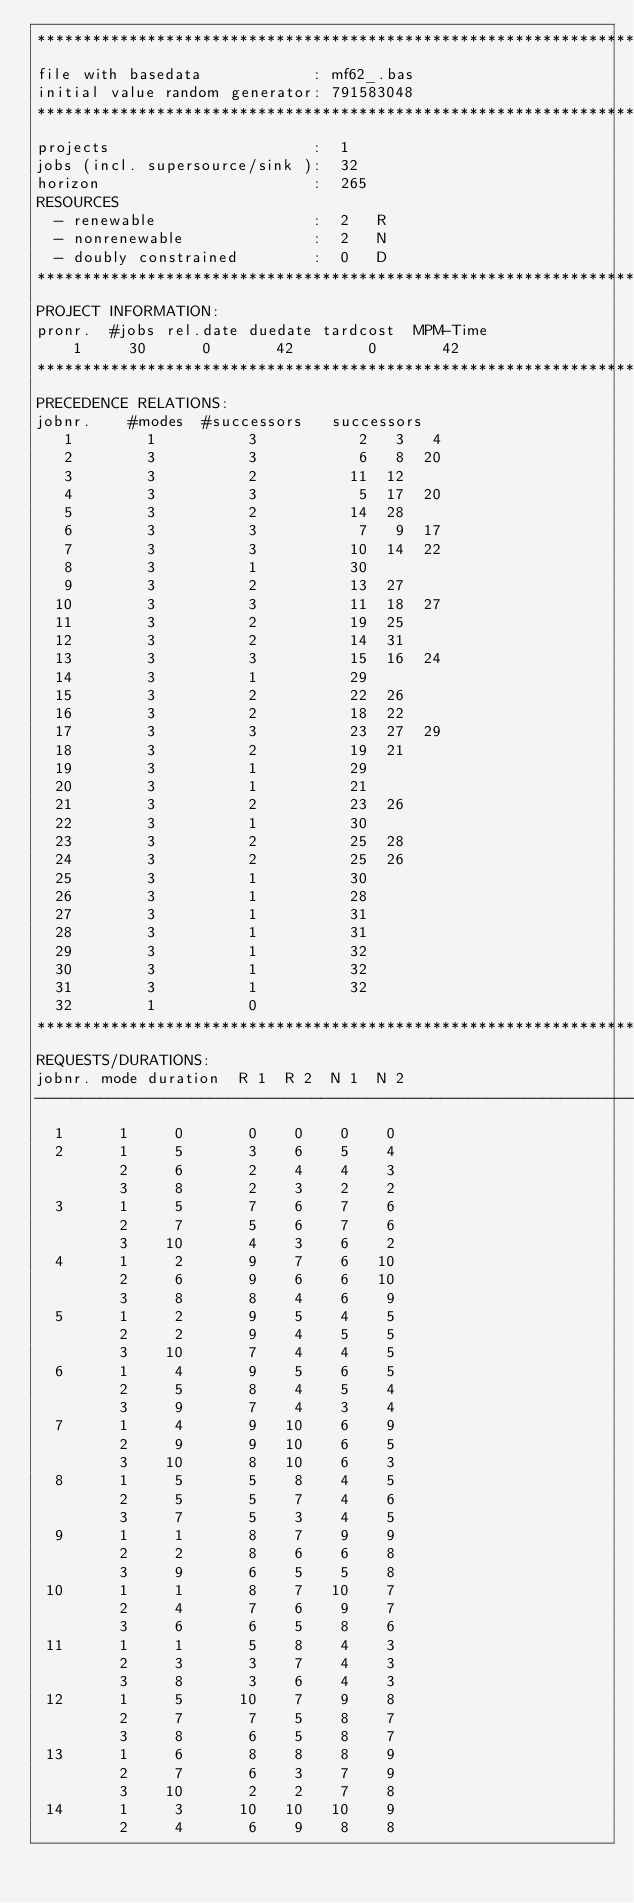<code> <loc_0><loc_0><loc_500><loc_500><_ObjectiveC_>************************************************************************
file with basedata            : mf62_.bas
initial value random generator: 791583048
************************************************************************
projects                      :  1
jobs (incl. supersource/sink ):  32
horizon                       :  265
RESOURCES
  - renewable                 :  2   R
  - nonrenewable              :  2   N
  - doubly constrained        :  0   D
************************************************************************
PROJECT INFORMATION:
pronr.  #jobs rel.date duedate tardcost  MPM-Time
    1     30      0       42        0       42
************************************************************************
PRECEDENCE RELATIONS:
jobnr.    #modes  #successors   successors
   1        1          3           2   3   4
   2        3          3           6   8  20
   3        3          2          11  12
   4        3          3           5  17  20
   5        3          2          14  28
   6        3          3           7   9  17
   7        3          3          10  14  22
   8        3          1          30
   9        3          2          13  27
  10        3          3          11  18  27
  11        3          2          19  25
  12        3          2          14  31
  13        3          3          15  16  24
  14        3          1          29
  15        3          2          22  26
  16        3          2          18  22
  17        3          3          23  27  29
  18        3          2          19  21
  19        3          1          29
  20        3          1          21
  21        3          2          23  26
  22        3          1          30
  23        3          2          25  28
  24        3          2          25  26
  25        3          1          30
  26        3          1          28
  27        3          1          31
  28        3          1          31
  29        3          1          32
  30        3          1          32
  31        3          1          32
  32        1          0        
************************************************************************
REQUESTS/DURATIONS:
jobnr. mode duration  R 1  R 2  N 1  N 2
------------------------------------------------------------------------
  1      1     0       0    0    0    0
  2      1     5       3    6    5    4
         2     6       2    4    4    3
         3     8       2    3    2    2
  3      1     5       7    6    7    6
         2     7       5    6    7    6
         3    10       4    3    6    2
  4      1     2       9    7    6   10
         2     6       9    6    6   10
         3     8       8    4    6    9
  5      1     2       9    5    4    5
         2     2       9    4    5    5
         3    10       7    4    4    5
  6      1     4       9    5    6    5
         2     5       8    4    5    4
         3     9       7    4    3    4
  7      1     4       9   10    6    9
         2     9       9   10    6    5
         3    10       8   10    6    3
  8      1     5       5    8    4    5
         2     5       5    7    4    6
         3     7       5    3    4    5
  9      1     1       8    7    9    9
         2     2       8    6    6    8
         3     9       6    5    5    8
 10      1     1       8    7   10    7
         2     4       7    6    9    7
         3     6       6    5    8    6
 11      1     1       5    8    4    3
         2     3       3    7    4    3
         3     8       3    6    4    3
 12      1     5      10    7    9    8
         2     7       7    5    8    7
         3     8       6    5    8    7
 13      1     6       8    8    8    9
         2     7       6    3    7    9
         3    10       2    2    7    8
 14      1     3      10   10   10    9
         2     4       6    9    8    8</code> 